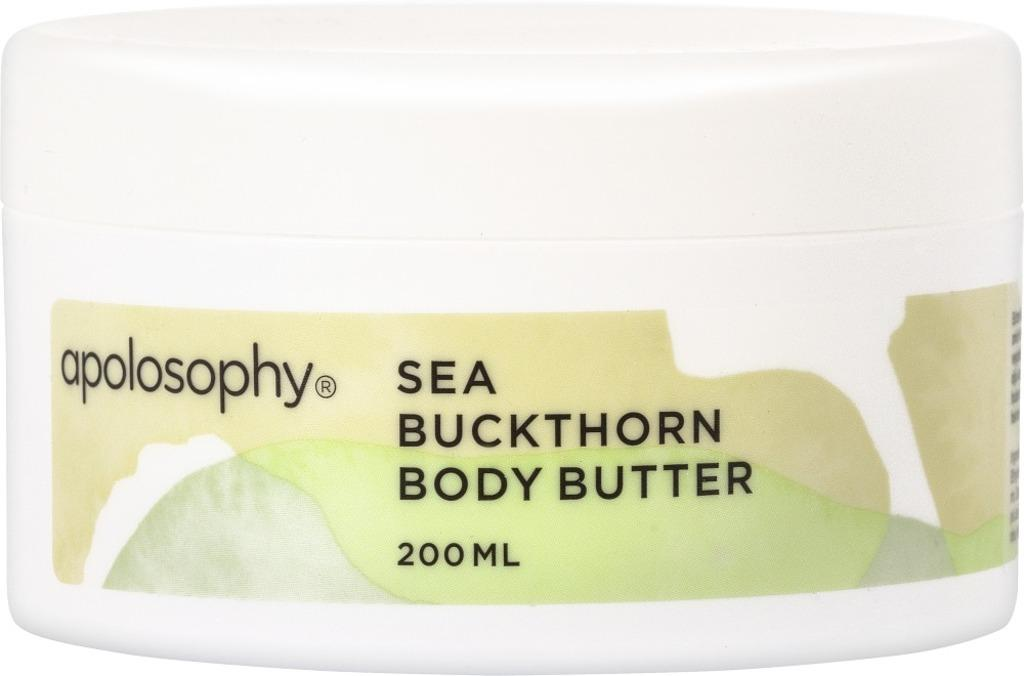<image>
Share a concise interpretation of the image provided. A tub of apolosophy Sea Buckthorn Body Butter. 